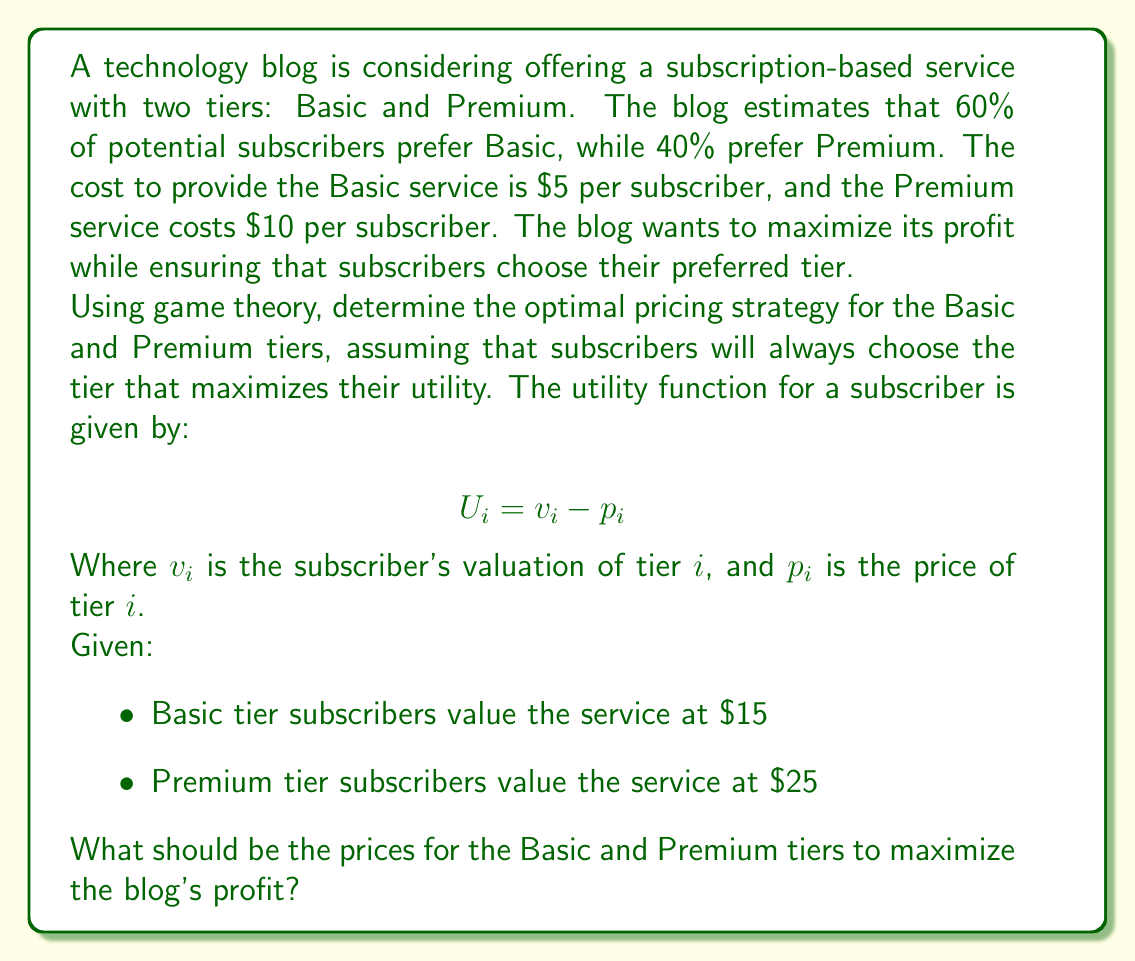Solve this math problem. To solve this problem, we'll use the concept of incentive compatibility from game theory. We need to ensure that each type of subscriber chooses their preferred tier while maximizing the blog's profit.

Let's define our variables:
$p_B$ = price of Basic tier
$p_P$ = price of Premium tier

Step 1: Set up incentive compatibility constraints

For Basic subscribers:
$15 - p_B \geq 15 - p_P$
$p_P - p_B \geq 0$ ... (1)

For Premium subscribers:
$25 - p_P \geq 25 - p_B$
$p_B - p_P \geq -10$ ... (2)

Step 2: Set up the profit function

Profit = Revenue - Cost
$\Pi = 0.6(p_B - 5) + 0.4(p_P - 10)$

Step 3: Maximize profit subject to constraints

To maximize profit, we want $p_B$ and $p_P$ to be as high as possible while satisfying constraints (1) and (2). The optimal solution will occur when both constraints are binding:

$p_P - p_B = 0$
$p_B - p_P = -10$

Solving these equations:
$p_P = p_B + 10$

Step 4: Substitute into the profit function

$\Pi = 0.6(p_B - 5) + 0.4(p_B + 10 - 10)$
$\Pi = 0.6p_B - 3 + 0.4p_B$
$\Pi = p_B - 3$

Step 5: Maximize $p_B$ subject to the valuation constraint

The maximum $p_B$ can be is $15 (the Basic subscriber's valuation)

Therefore:
$p_B = 15$
$p_P = 25$

Step 6: Calculate maximum profit

$\Pi = 15 - 3 = 12$ per subscriber
Answer: The optimal pricing strategy is:
Basic tier: $p_B = $15
Premium tier: $p_P = $25

This strategy maximizes the blog's profit at $12 per subscriber while ensuring that each type of subscriber chooses their preferred tier. 